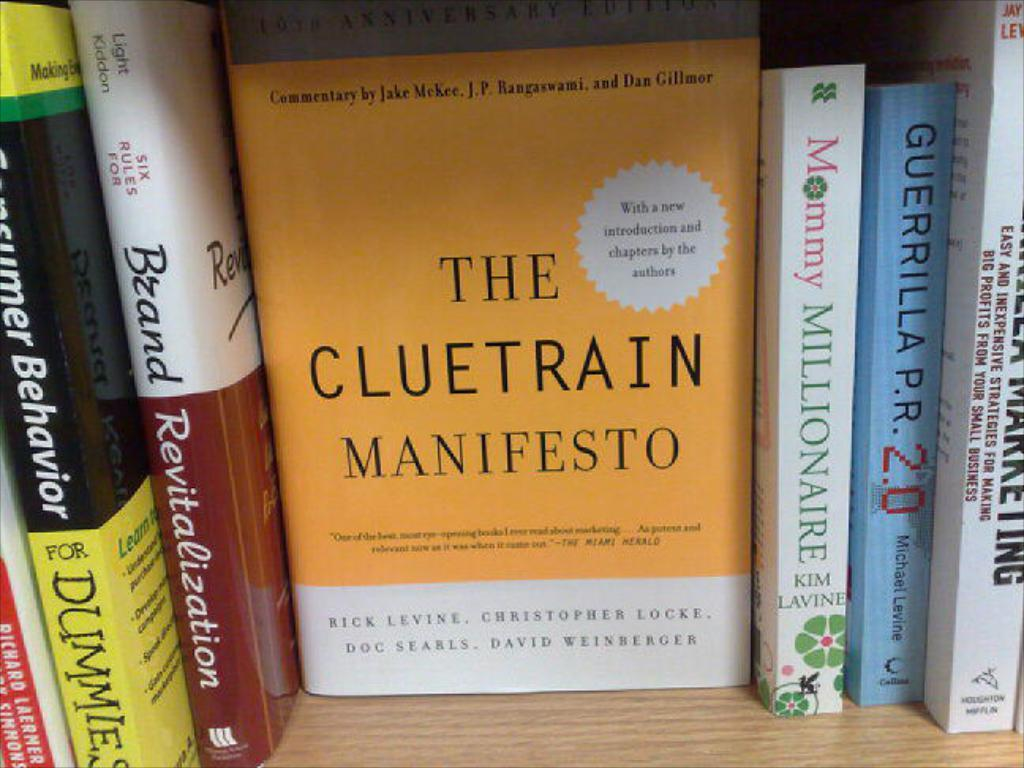<image>
Present a compact description of the photo's key features. The book The Cluetrain Manifesto sits on a shelf facing the camera. 